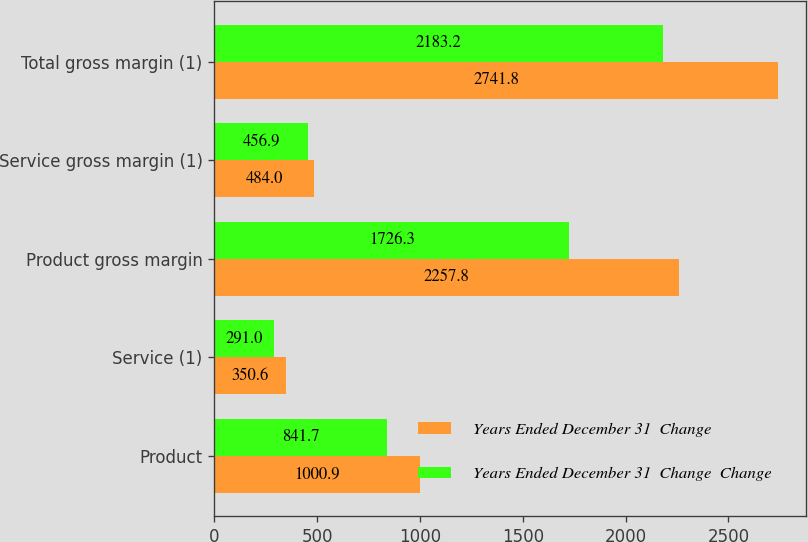Convert chart. <chart><loc_0><loc_0><loc_500><loc_500><stacked_bar_chart><ecel><fcel>Product<fcel>Service (1)<fcel>Product gross margin<fcel>Service gross margin (1)<fcel>Total gross margin (1)<nl><fcel>Years Ended December 31  Change<fcel>1000.9<fcel>350.6<fcel>2257.8<fcel>484<fcel>2741.8<nl><fcel>Years Ended December 31  Change  Change<fcel>841.7<fcel>291<fcel>1726.3<fcel>456.9<fcel>2183.2<nl></chart> 